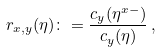Convert formula to latex. <formula><loc_0><loc_0><loc_500><loc_500>r _ { x , y } ( \eta ) \colon = \frac { c _ { y } ( \eta ^ { x - } ) } { c _ { y } ( \eta ) } \, ,</formula> 